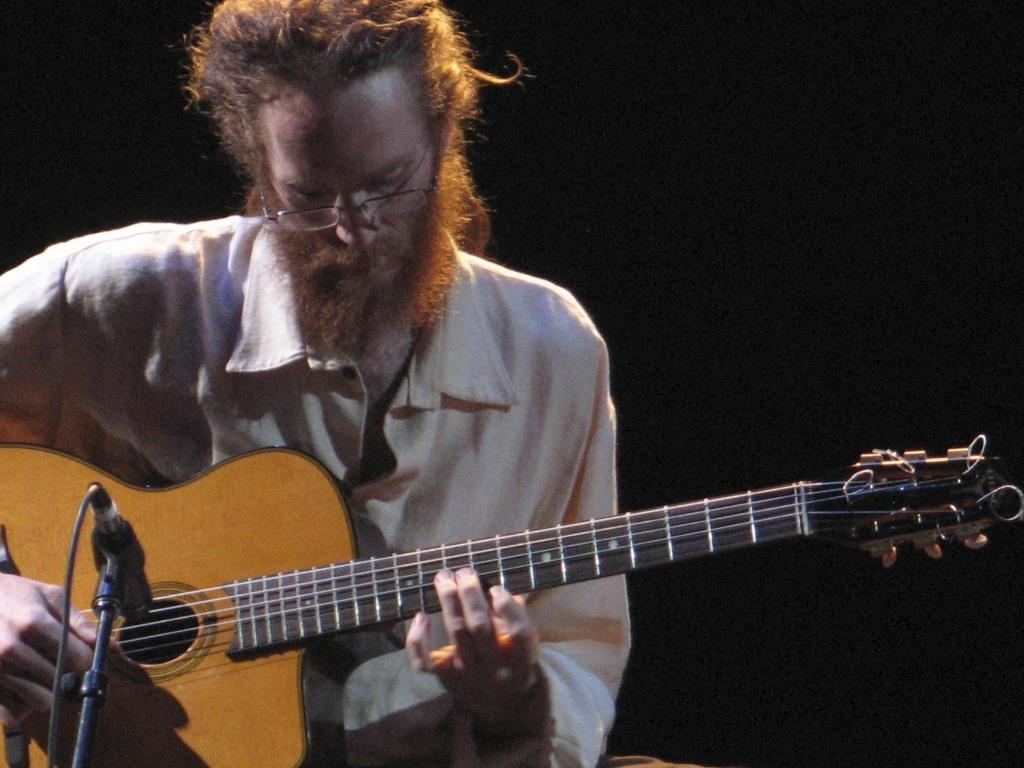Who is in the image? There is a person in the image. What is the person wearing? The person is wearing a white shirt. What is the person doing in the image? The person is playing a guitar. What object is located at the left side of the image? There is a microphone at the left side of the image. Are there any fairies visible in the image? No, there are no fairies present in the image. What type of payment is being made for the person's performance in the image? There is no indication of payment being made in the image; it only shows a person playing a guitar and a microphone. 